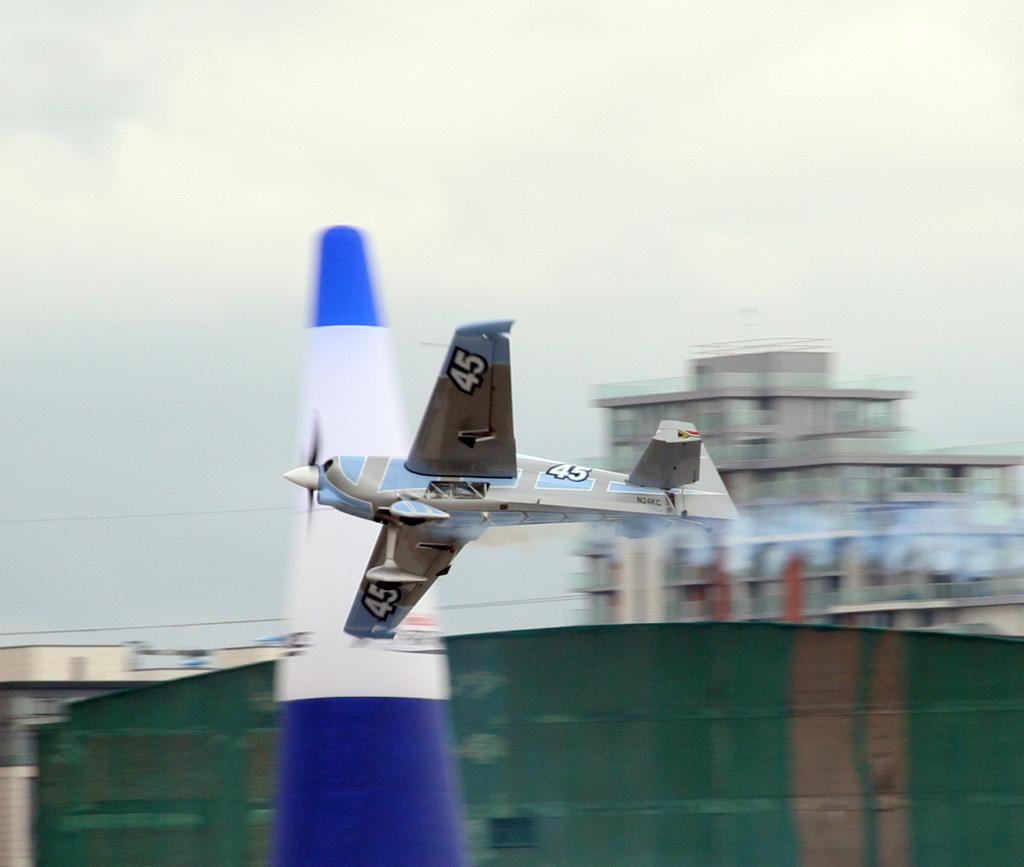<image>
Write a terse but informative summary of the picture. The small airplane has number 45 on its body and both wings. 